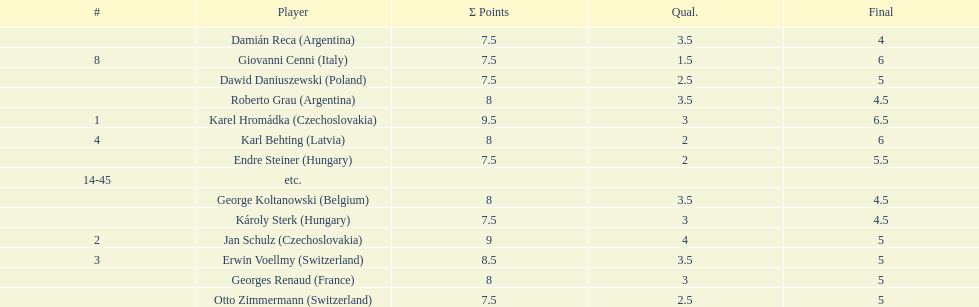Jan schulz is ranked immediately below which player? Karel Hromádka. 